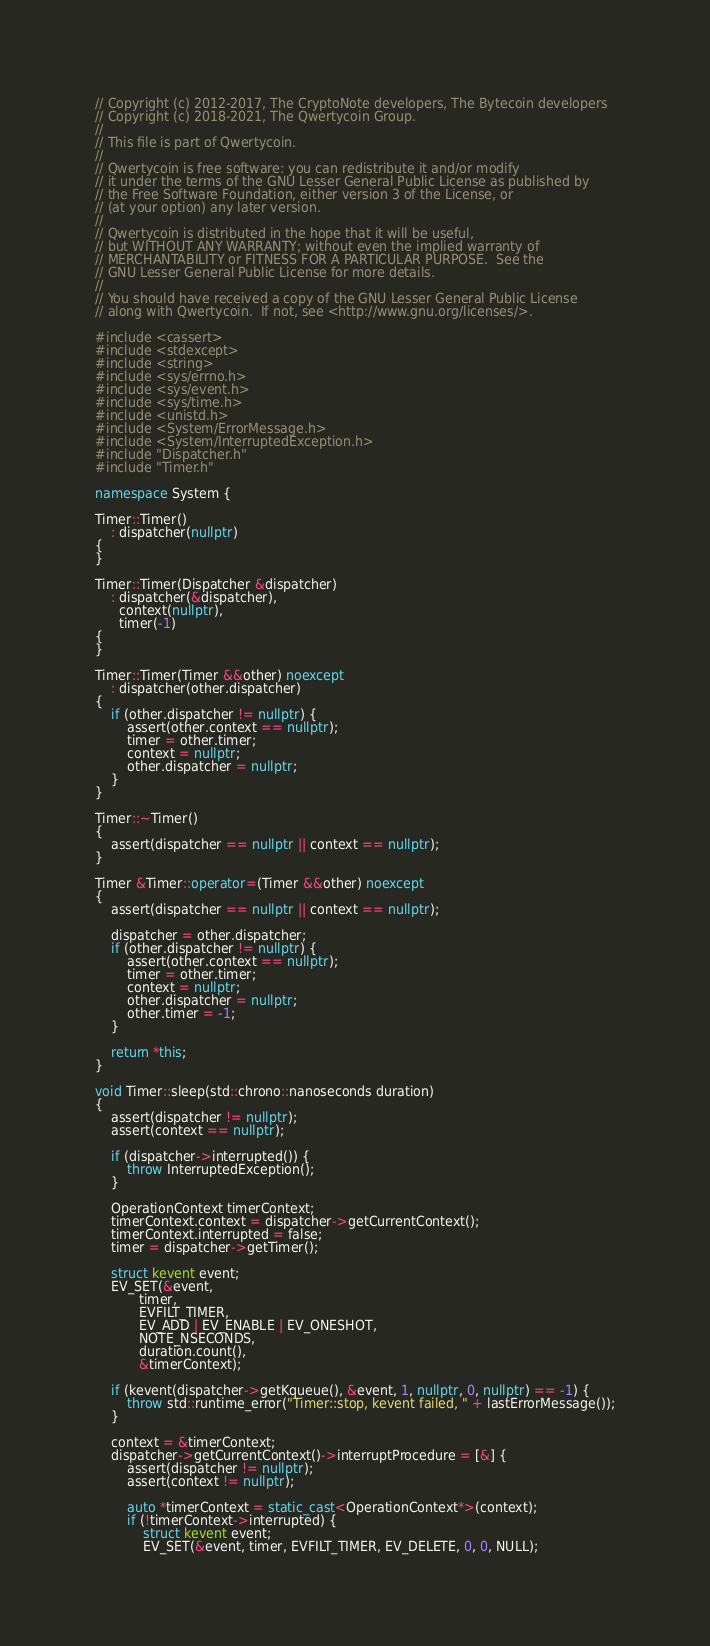<code> <loc_0><loc_0><loc_500><loc_500><_C++_>// Copyright (c) 2012-2017, The CryptoNote developers, The Bytecoin developers
// Copyright (c) 2018-2021, The Qwertycoin Group.
//
// This file is part of Qwertycoin.
//
// Qwertycoin is free software: you can redistribute it and/or modify
// it under the terms of the GNU Lesser General Public License as published by
// the Free Software Foundation, either version 3 of the License, or
// (at your option) any later version.
//
// Qwertycoin is distributed in the hope that it will be useful,
// but WITHOUT ANY WARRANTY; without even the implied warranty of
// MERCHANTABILITY or FITNESS FOR A PARTICULAR PURPOSE.  See the
// GNU Lesser General Public License for more details.
//
// You should have received a copy of the GNU Lesser General Public License
// along with Qwertycoin.  If not, see <http://www.gnu.org/licenses/>.

#include <cassert>
#include <stdexcept>
#include <string>
#include <sys/errno.h>
#include <sys/event.h>
#include <sys/time.h>
#include <unistd.h>
#include <System/ErrorMessage.h>
#include <System/InterruptedException.h>
#include "Dispatcher.h"
#include "Timer.h"

namespace System {

Timer::Timer()
    : dispatcher(nullptr)
{
}

Timer::Timer(Dispatcher &dispatcher)
    : dispatcher(&dispatcher),
      context(nullptr),
      timer(-1)
{
}

Timer::Timer(Timer &&other) noexcept
    : dispatcher(other.dispatcher)
{
    if (other.dispatcher != nullptr) {
        assert(other.context == nullptr);
        timer = other.timer;
        context = nullptr;
        other.dispatcher = nullptr;
    }
}

Timer::~Timer()
{
    assert(dispatcher == nullptr || context == nullptr);
}

Timer &Timer::operator=(Timer &&other) noexcept
{
    assert(dispatcher == nullptr || context == nullptr);

    dispatcher = other.dispatcher;
    if (other.dispatcher != nullptr) {
        assert(other.context == nullptr);
        timer = other.timer;
        context = nullptr;
        other.dispatcher = nullptr;
        other.timer = -1;
    }

    return *this;
}

void Timer::sleep(std::chrono::nanoseconds duration)
{
    assert(dispatcher != nullptr);
    assert(context == nullptr);

    if (dispatcher->interrupted()) {
        throw InterruptedException();
    }

    OperationContext timerContext;
    timerContext.context = dispatcher->getCurrentContext();
    timerContext.interrupted = false;
    timer = dispatcher->getTimer();

    struct kevent event;
    EV_SET(&event,
           timer,
           EVFILT_TIMER,
           EV_ADD | EV_ENABLE | EV_ONESHOT,
           NOTE_NSECONDS,
           duration.count(),
           &timerContext);

    if (kevent(dispatcher->getKqueue(), &event, 1, nullptr, 0, nullptr) == -1) {
        throw std::runtime_error("Timer::stop, kevent failed, " + lastErrorMessage());
    }

    context = &timerContext;
    dispatcher->getCurrentContext()->interruptProcedure = [&] {
        assert(dispatcher != nullptr);
        assert(context != nullptr);

        auto *timerContext = static_cast<OperationContext*>(context);
        if (!timerContext->interrupted) {
            struct kevent event;
            EV_SET(&event, timer, EVFILT_TIMER, EV_DELETE, 0, 0, NULL);
</code> 